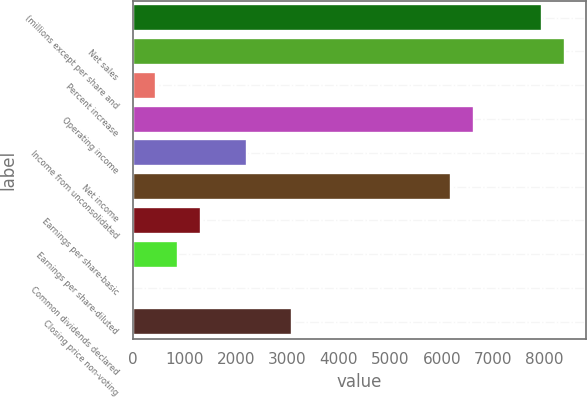<chart> <loc_0><loc_0><loc_500><loc_500><bar_chart><fcel>(millions except per share and<fcel>Net sales<fcel>Percent increase<fcel>Operating income<fcel>Income from unconsolidated<fcel>Net income<fcel>Earnings per share-basic<fcel>Earnings per share-diluted<fcel>Common dividends declared<fcel>Closing price non-voting<nl><fcel>7944.55<fcel>8385.83<fcel>442.79<fcel>6620.71<fcel>2207.91<fcel>6179.43<fcel>1325.35<fcel>884.07<fcel>1.51<fcel>3090.47<nl></chart> 